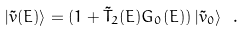<formula> <loc_0><loc_0><loc_500><loc_500>| \tilde { v } ( E ) \rangle = ( 1 + \tilde { T } _ { 2 } ( E ) G _ { 0 } ( E ) ) \, | \tilde { v } _ { 0 } \rangle \ .</formula> 